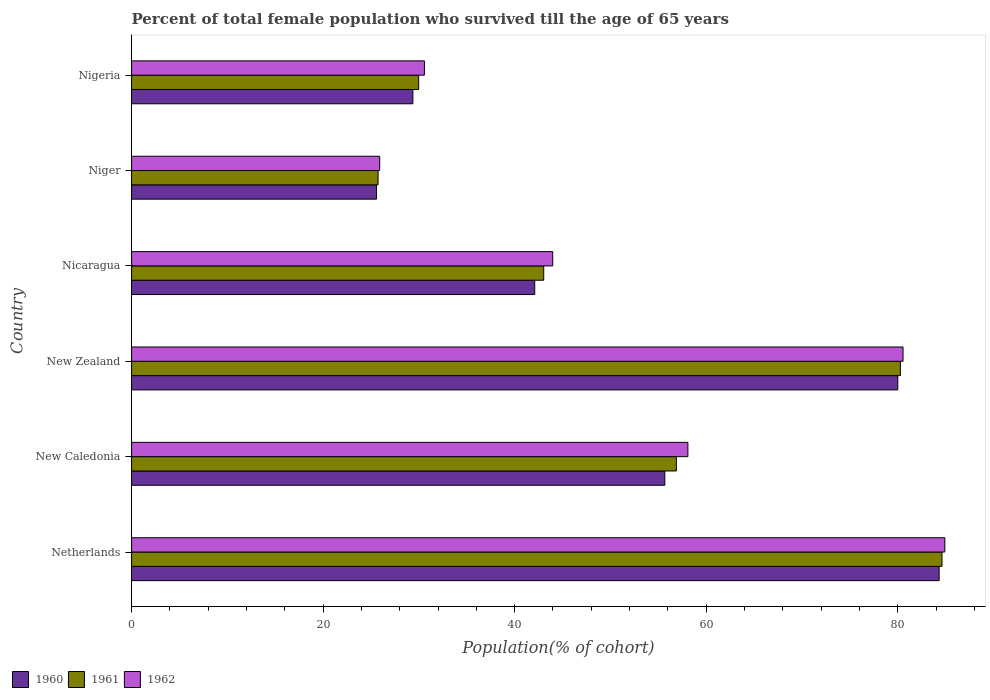How many different coloured bars are there?
Make the answer very short. 3. How many groups of bars are there?
Keep it short and to the point. 6. Are the number of bars on each tick of the Y-axis equal?
Give a very brief answer. Yes. How many bars are there on the 6th tick from the bottom?
Offer a terse response. 3. What is the label of the 6th group of bars from the top?
Your answer should be very brief. Netherlands. What is the percentage of total female population who survived till the age of 65 years in 1960 in Netherlands?
Your answer should be very brief. 84.32. Across all countries, what is the maximum percentage of total female population who survived till the age of 65 years in 1962?
Provide a short and direct response. 84.91. Across all countries, what is the minimum percentage of total female population who survived till the age of 65 years in 1962?
Your response must be concise. 25.91. In which country was the percentage of total female population who survived till the age of 65 years in 1961 minimum?
Ensure brevity in your answer.  Niger. What is the total percentage of total female population who survived till the age of 65 years in 1960 in the graph?
Give a very brief answer. 317.03. What is the difference between the percentage of total female population who survived till the age of 65 years in 1962 in Netherlands and that in Nigeria?
Keep it short and to the point. 54.34. What is the difference between the percentage of total female population who survived till the age of 65 years in 1962 in Niger and the percentage of total female population who survived till the age of 65 years in 1961 in New Caledonia?
Keep it short and to the point. -30.97. What is the average percentage of total female population who survived till the age of 65 years in 1960 per country?
Offer a very short reply. 52.84. What is the difference between the percentage of total female population who survived till the age of 65 years in 1962 and percentage of total female population who survived till the age of 65 years in 1960 in Niger?
Your answer should be very brief. 0.34. In how many countries, is the percentage of total female population who survived till the age of 65 years in 1962 greater than 84 %?
Make the answer very short. 1. What is the ratio of the percentage of total female population who survived till the age of 65 years in 1961 in New Zealand to that in Nigeria?
Ensure brevity in your answer.  2.68. Is the percentage of total female population who survived till the age of 65 years in 1962 in New Caledonia less than that in Nicaragua?
Your response must be concise. No. Is the difference between the percentage of total female population who survived till the age of 65 years in 1962 in Netherlands and New Zealand greater than the difference between the percentage of total female population who survived till the age of 65 years in 1960 in Netherlands and New Zealand?
Your answer should be compact. Yes. What is the difference between the highest and the second highest percentage of total female population who survived till the age of 65 years in 1960?
Keep it short and to the point. 4.32. What is the difference between the highest and the lowest percentage of total female population who survived till the age of 65 years in 1960?
Provide a succinct answer. 58.75. Is it the case that in every country, the sum of the percentage of total female population who survived till the age of 65 years in 1960 and percentage of total female population who survived till the age of 65 years in 1962 is greater than the percentage of total female population who survived till the age of 65 years in 1961?
Your answer should be compact. Yes. Are all the bars in the graph horizontal?
Make the answer very short. Yes. How many countries are there in the graph?
Your answer should be compact. 6. What is the difference between two consecutive major ticks on the X-axis?
Provide a succinct answer. 20. Does the graph contain any zero values?
Your answer should be very brief. No. Does the graph contain grids?
Provide a short and direct response. No. How many legend labels are there?
Your response must be concise. 3. How are the legend labels stacked?
Provide a short and direct response. Horizontal. What is the title of the graph?
Your response must be concise. Percent of total female population who survived till the age of 65 years. Does "2003" appear as one of the legend labels in the graph?
Make the answer very short. No. What is the label or title of the X-axis?
Make the answer very short. Population(% of cohort). What is the label or title of the Y-axis?
Offer a very short reply. Country. What is the Population(% of cohort) of 1960 in Netherlands?
Give a very brief answer. 84.32. What is the Population(% of cohort) of 1961 in Netherlands?
Make the answer very short. 84.62. What is the Population(% of cohort) in 1962 in Netherlands?
Offer a terse response. 84.91. What is the Population(% of cohort) of 1960 in New Caledonia?
Provide a succinct answer. 55.68. What is the Population(% of cohort) in 1961 in New Caledonia?
Provide a succinct answer. 56.88. What is the Population(% of cohort) in 1962 in New Caledonia?
Give a very brief answer. 58.09. What is the Population(% of cohort) of 1960 in New Zealand?
Keep it short and to the point. 80. What is the Population(% of cohort) of 1961 in New Zealand?
Ensure brevity in your answer.  80.28. What is the Population(% of cohort) in 1962 in New Zealand?
Make the answer very short. 80.55. What is the Population(% of cohort) in 1960 in Nicaragua?
Your response must be concise. 42.09. What is the Population(% of cohort) in 1961 in Nicaragua?
Give a very brief answer. 43.03. What is the Population(% of cohort) in 1962 in Nicaragua?
Your answer should be compact. 43.97. What is the Population(% of cohort) of 1960 in Niger?
Provide a short and direct response. 25.57. What is the Population(% of cohort) in 1961 in Niger?
Provide a succinct answer. 25.74. What is the Population(% of cohort) of 1962 in Niger?
Offer a very short reply. 25.91. What is the Population(% of cohort) of 1960 in Nigeria?
Offer a very short reply. 29.37. What is the Population(% of cohort) in 1961 in Nigeria?
Offer a terse response. 29.97. What is the Population(% of cohort) in 1962 in Nigeria?
Provide a short and direct response. 30.58. Across all countries, what is the maximum Population(% of cohort) of 1960?
Make the answer very short. 84.32. Across all countries, what is the maximum Population(% of cohort) in 1961?
Offer a terse response. 84.62. Across all countries, what is the maximum Population(% of cohort) in 1962?
Provide a succinct answer. 84.91. Across all countries, what is the minimum Population(% of cohort) of 1960?
Your answer should be very brief. 25.57. Across all countries, what is the minimum Population(% of cohort) in 1961?
Offer a terse response. 25.74. Across all countries, what is the minimum Population(% of cohort) of 1962?
Offer a terse response. 25.91. What is the total Population(% of cohort) in 1960 in the graph?
Keep it short and to the point. 317.03. What is the total Population(% of cohort) in 1961 in the graph?
Offer a terse response. 320.51. What is the total Population(% of cohort) in 1962 in the graph?
Offer a terse response. 324. What is the difference between the Population(% of cohort) of 1960 in Netherlands and that in New Caledonia?
Your answer should be very brief. 28.64. What is the difference between the Population(% of cohort) of 1961 in Netherlands and that in New Caledonia?
Provide a short and direct response. 27.74. What is the difference between the Population(% of cohort) in 1962 in Netherlands and that in New Caledonia?
Make the answer very short. 26.83. What is the difference between the Population(% of cohort) of 1960 in Netherlands and that in New Zealand?
Keep it short and to the point. 4.32. What is the difference between the Population(% of cohort) in 1961 in Netherlands and that in New Zealand?
Your response must be concise. 4.34. What is the difference between the Population(% of cohort) of 1962 in Netherlands and that in New Zealand?
Your answer should be compact. 4.36. What is the difference between the Population(% of cohort) of 1960 in Netherlands and that in Nicaragua?
Your answer should be compact. 42.23. What is the difference between the Population(% of cohort) in 1961 in Netherlands and that in Nicaragua?
Your response must be concise. 41.58. What is the difference between the Population(% of cohort) of 1962 in Netherlands and that in Nicaragua?
Your response must be concise. 40.94. What is the difference between the Population(% of cohort) of 1960 in Netherlands and that in Niger?
Offer a terse response. 58.75. What is the difference between the Population(% of cohort) in 1961 in Netherlands and that in Niger?
Your answer should be very brief. 58.88. What is the difference between the Population(% of cohort) of 1962 in Netherlands and that in Niger?
Your answer should be very brief. 59.01. What is the difference between the Population(% of cohort) in 1960 in Netherlands and that in Nigeria?
Your answer should be very brief. 54.95. What is the difference between the Population(% of cohort) in 1961 in Netherlands and that in Nigeria?
Your answer should be very brief. 54.64. What is the difference between the Population(% of cohort) of 1962 in Netherlands and that in Nigeria?
Your answer should be compact. 54.34. What is the difference between the Population(% of cohort) in 1960 in New Caledonia and that in New Zealand?
Provide a short and direct response. -24.33. What is the difference between the Population(% of cohort) of 1961 in New Caledonia and that in New Zealand?
Provide a short and direct response. -23.4. What is the difference between the Population(% of cohort) of 1962 in New Caledonia and that in New Zealand?
Offer a very short reply. -22.46. What is the difference between the Population(% of cohort) of 1960 in New Caledonia and that in Nicaragua?
Ensure brevity in your answer.  13.58. What is the difference between the Population(% of cohort) in 1961 in New Caledonia and that in Nicaragua?
Provide a succinct answer. 13.85. What is the difference between the Population(% of cohort) in 1962 in New Caledonia and that in Nicaragua?
Your answer should be compact. 14.11. What is the difference between the Population(% of cohort) in 1960 in New Caledonia and that in Niger?
Your answer should be compact. 30.11. What is the difference between the Population(% of cohort) of 1961 in New Caledonia and that in Niger?
Keep it short and to the point. 31.14. What is the difference between the Population(% of cohort) in 1962 in New Caledonia and that in Niger?
Your response must be concise. 32.18. What is the difference between the Population(% of cohort) in 1960 in New Caledonia and that in Nigeria?
Provide a short and direct response. 26.3. What is the difference between the Population(% of cohort) of 1961 in New Caledonia and that in Nigeria?
Offer a terse response. 26.91. What is the difference between the Population(% of cohort) in 1962 in New Caledonia and that in Nigeria?
Make the answer very short. 27.51. What is the difference between the Population(% of cohort) in 1960 in New Zealand and that in Nicaragua?
Ensure brevity in your answer.  37.91. What is the difference between the Population(% of cohort) in 1961 in New Zealand and that in Nicaragua?
Keep it short and to the point. 37.24. What is the difference between the Population(% of cohort) in 1962 in New Zealand and that in Nicaragua?
Offer a very short reply. 36.58. What is the difference between the Population(% of cohort) of 1960 in New Zealand and that in Niger?
Provide a short and direct response. 54.43. What is the difference between the Population(% of cohort) of 1961 in New Zealand and that in Niger?
Your answer should be compact. 54.54. What is the difference between the Population(% of cohort) in 1962 in New Zealand and that in Niger?
Ensure brevity in your answer.  54.64. What is the difference between the Population(% of cohort) of 1960 in New Zealand and that in Nigeria?
Ensure brevity in your answer.  50.63. What is the difference between the Population(% of cohort) in 1961 in New Zealand and that in Nigeria?
Your answer should be very brief. 50.3. What is the difference between the Population(% of cohort) in 1962 in New Zealand and that in Nigeria?
Provide a short and direct response. 49.97. What is the difference between the Population(% of cohort) in 1960 in Nicaragua and that in Niger?
Your response must be concise. 16.53. What is the difference between the Population(% of cohort) of 1961 in Nicaragua and that in Niger?
Your response must be concise. 17.3. What is the difference between the Population(% of cohort) in 1962 in Nicaragua and that in Niger?
Offer a very short reply. 18.07. What is the difference between the Population(% of cohort) of 1960 in Nicaragua and that in Nigeria?
Your answer should be compact. 12.72. What is the difference between the Population(% of cohort) in 1961 in Nicaragua and that in Nigeria?
Give a very brief answer. 13.06. What is the difference between the Population(% of cohort) in 1962 in Nicaragua and that in Nigeria?
Make the answer very short. 13.4. What is the difference between the Population(% of cohort) of 1960 in Niger and that in Nigeria?
Your answer should be very brief. -3.8. What is the difference between the Population(% of cohort) in 1961 in Niger and that in Nigeria?
Your answer should be very brief. -4.24. What is the difference between the Population(% of cohort) of 1962 in Niger and that in Nigeria?
Your answer should be compact. -4.67. What is the difference between the Population(% of cohort) in 1960 in Netherlands and the Population(% of cohort) in 1961 in New Caledonia?
Keep it short and to the point. 27.44. What is the difference between the Population(% of cohort) in 1960 in Netherlands and the Population(% of cohort) in 1962 in New Caledonia?
Offer a very short reply. 26.23. What is the difference between the Population(% of cohort) in 1961 in Netherlands and the Population(% of cohort) in 1962 in New Caledonia?
Provide a short and direct response. 26.53. What is the difference between the Population(% of cohort) in 1960 in Netherlands and the Population(% of cohort) in 1961 in New Zealand?
Provide a short and direct response. 4.04. What is the difference between the Population(% of cohort) of 1960 in Netherlands and the Population(% of cohort) of 1962 in New Zealand?
Ensure brevity in your answer.  3.77. What is the difference between the Population(% of cohort) in 1961 in Netherlands and the Population(% of cohort) in 1962 in New Zealand?
Keep it short and to the point. 4.07. What is the difference between the Population(% of cohort) of 1960 in Netherlands and the Population(% of cohort) of 1961 in Nicaragua?
Your response must be concise. 41.29. What is the difference between the Population(% of cohort) of 1960 in Netherlands and the Population(% of cohort) of 1962 in Nicaragua?
Your answer should be compact. 40.35. What is the difference between the Population(% of cohort) in 1961 in Netherlands and the Population(% of cohort) in 1962 in Nicaragua?
Make the answer very short. 40.64. What is the difference between the Population(% of cohort) in 1960 in Netherlands and the Population(% of cohort) in 1961 in Niger?
Ensure brevity in your answer.  58.58. What is the difference between the Population(% of cohort) in 1960 in Netherlands and the Population(% of cohort) in 1962 in Niger?
Your answer should be compact. 58.41. What is the difference between the Population(% of cohort) of 1961 in Netherlands and the Population(% of cohort) of 1962 in Niger?
Offer a very short reply. 58.71. What is the difference between the Population(% of cohort) in 1960 in Netherlands and the Population(% of cohort) in 1961 in Nigeria?
Provide a short and direct response. 54.35. What is the difference between the Population(% of cohort) of 1960 in Netherlands and the Population(% of cohort) of 1962 in Nigeria?
Offer a very short reply. 53.74. What is the difference between the Population(% of cohort) of 1961 in Netherlands and the Population(% of cohort) of 1962 in Nigeria?
Keep it short and to the point. 54.04. What is the difference between the Population(% of cohort) of 1960 in New Caledonia and the Population(% of cohort) of 1961 in New Zealand?
Make the answer very short. -24.6. What is the difference between the Population(% of cohort) of 1960 in New Caledonia and the Population(% of cohort) of 1962 in New Zealand?
Make the answer very short. -24.87. What is the difference between the Population(% of cohort) of 1961 in New Caledonia and the Population(% of cohort) of 1962 in New Zealand?
Ensure brevity in your answer.  -23.67. What is the difference between the Population(% of cohort) of 1960 in New Caledonia and the Population(% of cohort) of 1961 in Nicaragua?
Make the answer very short. 12.64. What is the difference between the Population(% of cohort) in 1960 in New Caledonia and the Population(% of cohort) in 1962 in Nicaragua?
Make the answer very short. 11.7. What is the difference between the Population(% of cohort) in 1961 in New Caledonia and the Population(% of cohort) in 1962 in Nicaragua?
Offer a terse response. 12.91. What is the difference between the Population(% of cohort) of 1960 in New Caledonia and the Population(% of cohort) of 1961 in Niger?
Offer a terse response. 29.94. What is the difference between the Population(% of cohort) of 1960 in New Caledonia and the Population(% of cohort) of 1962 in Niger?
Make the answer very short. 29.77. What is the difference between the Population(% of cohort) in 1961 in New Caledonia and the Population(% of cohort) in 1962 in Niger?
Give a very brief answer. 30.97. What is the difference between the Population(% of cohort) of 1960 in New Caledonia and the Population(% of cohort) of 1961 in Nigeria?
Give a very brief answer. 25.7. What is the difference between the Population(% of cohort) in 1960 in New Caledonia and the Population(% of cohort) in 1962 in Nigeria?
Your response must be concise. 25.1. What is the difference between the Population(% of cohort) in 1961 in New Caledonia and the Population(% of cohort) in 1962 in Nigeria?
Ensure brevity in your answer.  26.3. What is the difference between the Population(% of cohort) in 1960 in New Zealand and the Population(% of cohort) in 1961 in Nicaragua?
Your answer should be compact. 36.97. What is the difference between the Population(% of cohort) in 1960 in New Zealand and the Population(% of cohort) in 1962 in Nicaragua?
Your answer should be very brief. 36.03. What is the difference between the Population(% of cohort) in 1961 in New Zealand and the Population(% of cohort) in 1962 in Nicaragua?
Your response must be concise. 36.3. What is the difference between the Population(% of cohort) of 1960 in New Zealand and the Population(% of cohort) of 1961 in Niger?
Make the answer very short. 54.27. What is the difference between the Population(% of cohort) of 1960 in New Zealand and the Population(% of cohort) of 1962 in Niger?
Your answer should be very brief. 54.1. What is the difference between the Population(% of cohort) in 1961 in New Zealand and the Population(% of cohort) in 1962 in Niger?
Your response must be concise. 54.37. What is the difference between the Population(% of cohort) in 1960 in New Zealand and the Population(% of cohort) in 1961 in Nigeria?
Offer a very short reply. 50.03. What is the difference between the Population(% of cohort) of 1960 in New Zealand and the Population(% of cohort) of 1962 in Nigeria?
Offer a terse response. 49.43. What is the difference between the Population(% of cohort) in 1961 in New Zealand and the Population(% of cohort) in 1962 in Nigeria?
Make the answer very short. 49.7. What is the difference between the Population(% of cohort) in 1960 in Nicaragua and the Population(% of cohort) in 1961 in Niger?
Offer a very short reply. 16.36. What is the difference between the Population(% of cohort) in 1960 in Nicaragua and the Population(% of cohort) in 1962 in Niger?
Keep it short and to the point. 16.19. What is the difference between the Population(% of cohort) of 1961 in Nicaragua and the Population(% of cohort) of 1962 in Niger?
Make the answer very short. 17.13. What is the difference between the Population(% of cohort) of 1960 in Nicaragua and the Population(% of cohort) of 1961 in Nigeria?
Your response must be concise. 12.12. What is the difference between the Population(% of cohort) in 1960 in Nicaragua and the Population(% of cohort) in 1962 in Nigeria?
Provide a short and direct response. 11.52. What is the difference between the Population(% of cohort) of 1961 in Nicaragua and the Population(% of cohort) of 1962 in Nigeria?
Provide a succinct answer. 12.46. What is the difference between the Population(% of cohort) of 1960 in Niger and the Population(% of cohort) of 1961 in Nigeria?
Offer a very short reply. -4.41. What is the difference between the Population(% of cohort) of 1960 in Niger and the Population(% of cohort) of 1962 in Nigeria?
Your response must be concise. -5.01. What is the difference between the Population(% of cohort) of 1961 in Niger and the Population(% of cohort) of 1962 in Nigeria?
Provide a succinct answer. -4.84. What is the average Population(% of cohort) of 1960 per country?
Offer a very short reply. 52.84. What is the average Population(% of cohort) of 1961 per country?
Your response must be concise. 53.42. What is the average Population(% of cohort) in 1962 per country?
Offer a very short reply. 54. What is the difference between the Population(% of cohort) of 1960 and Population(% of cohort) of 1961 in Netherlands?
Ensure brevity in your answer.  -0.3. What is the difference between the Population(% of cohort) in 1960 and Population(% of cohort) in 1962 in Netherlands?
Ensure brevity in your answer.  -0.59. What is the difference between the Population(% of cohort) in 1961 and Population(% of cohort) in 1962 in Netherlands?
Provide a short and direct response. -0.3. What is the difference between the Population(% of cohort) in 1960 and Population(% of cohort) in 1961 in New Caledonia?
Provide a short and direct response. -1.21. What is the difference between the Population(% of cohort) of 1960 and Population(% of cohort) of 1962 in New Caledonia?
Give a very brief answer. -2.41. What is the difference between the Population(% of cohort) of 1961 and Population(% of cohort) of 1962 in New Caledonia?
Your answer should be compact. -1.21. What is the difference between the Population(% of cohort) in 1960 and Population(% of cohort) in 1961 in New Zealand?
Give a very brief answer. -0.27. What is the difference between the Population(% of cohort) in 1960 and Population(% of cohort) in 1962 in New Zealand?
Ensure brevity in your answer.  -0.55. What is the difference between the Population(% of cohort) of 1961 and Population(% of cohort) of 1962 in New Zealand?
Make the answer very short. -0.27. What is the difference between the Population(% of cohort) in 1960 and Population(% of cohort) in 1961 in Nicaragua?
Keep it short and to the point. -0.94. What is the difference between the Population(% of cohort) of 1960 and Population(% of cohort) of 1962 in Nicaragua?
Offer a terse response. -1.88. What is the difference between the Population(% of cohort) of 1961 and Population(% of cohort) of 1962 in Nicaragua?
Make the answer very short. -0.94. What is the difference between the Population(% of cohort) of 1960 and Population(% of cohort) of 1961 in Niger?
Your answer should be very brief. -0.17. What is the difference between the Population(% of cohort) in 1960 and Population(% of cohort) in 1962 in Niger?
Your response must be concise. -0.34. What is the difference between the Population(% of cohort) in 1961 and Population(% of cohort) in 1962 in Niger?
Make the answer very short. -0.17. What is the difference between the Population(% of cohort) in 1960 and Population(% of cohort) in 1961 in Nigeria?
Your response must be concise. -0.6. What is the difference between the Population(% of cohort) of 1960 and Population(% of cohort) of 1962 in Nigeria?
Offer a very short reply. -1.21. What is the difference between the Population(% of cohort) in 1961 and Population(% of cohort) in 1962 in Nigeria?
Offer a very short reply. -0.6. What is the ratio of the Population(% of cohort) in 1960 in Netherlands to that in New Caledonia?
Give a very brief answer. 1.51. What is the ratio of the Population(% of cohort) in 1961 in Netherlands to that in New Caledonia?
Your response must be concise. 1.49. What is the ratio of the Population(% of cohort) in 1962 in Netherlands to that in New Caledonia?
Ensure brevity in your answer.  1.46. What is the ratio of the Population(% of cohort) of 1960 in Netherlands to that in New Zealand?
Give a very brief answer. 1.05. What is the ratio of the Population(% of cohort) in 1961 in Netherlands to that in New Zealand?
Provide a succinct answer. 1.05. What is the ratio of the Population(% of cohort) of 1962 in Netherlands to that in New Zealand?
Keep it short and to the point. 1.05. What is the ratio of the Population(% of cohort) of 1960 in Netherlands to that in Nicaragua?
Give a very brief answer. 2. What is the ratio of the Population(% of cohort) of 1961 in Netherlands to that in Nicaragua?
Offer a very short reply. 1.97. What is the ratio of the Population(% of cohort) of 1962 in Netherlands to that in Nicaragua?
Your response must be concise. 1.93. What is the ratio of the Population(% of cohort) of 1960 in Netherlands to that in Niger?
Keep it short and to the point. 3.3. What is the ratio of the Population(% of cohort) of 1961 in Netherlands to that in Niger?
Keep it short and to the point. 3.29. What is the ratio of the Population(% of cohort) of 1962 in Netherlands to that in Niger?
Give a very brief answer. 3.28. What is the ratio of the Population(% of cohort) in 1960 in Netherlands to that in Nigeria?
Make the answer very short. 2.87. What is the ratio of the Population(% of cohort) in 1961 in Netherlands to that in Nigeria?
Provide a short and direct response. 2.82. What is the ratio of the Population(% of cohort) of 1962 in Netherlands to that in Nigeria?
Provide a succinct answer. 2.78. What is the ratio of the Population(% of cohort) of 1960 in New Caledonia to that in New Zealand?
Your answer should be compact. 0.7. What is the ratio of the Population(% of cohort) of 1961 in New Caledonia to that in New Zealand?
Keep it short and to the point. 0.71. What is the ratio of the Population(% of cohort) in 1962 in New Caledonia to that in New Zealand?
Give a very brief answer. 0.72. What is the ratio of the Population(% of cohort) of 1960 in New Caledonia to that in Nicaragua?
Keep it short and to the point. 1.32. What is the ratio of the Population(% of cohort) in 1961 in New Caledonia to that in Nicaragua?
Offer a very short reply. 1.32. What is the ratio of the Population(% of cohort) of 1962 in New Caledonia to that in Nicaragua?
Keep it short and to the point. 1.32. What is the ratio of the Population(% of cohort) in 1960 in New Caledonia to that in Niger?
Offer a terse response. 2.18. What is the ratio of the Population(% of cohort) in 1961 in New Caledonia to that in Niger?
Make the answer very short. 2.21. What is the ratio of the Population(% of cohort) of 1962 in New Caledonia to that in Niger?
Ensure brevity in your answer.  2.24. What is the ratio of the Population(% of cohort) of 1960 in New Caledonia to that in Nigeria?
Your answer should be compact. 1.9. What is the ratio of the Population(% of cohort) in 1961 in New Caledonia to that in Nigeria?
Provide a succinct answer. 1.9. What is the ratio of the Population(% of cohort) in 1962 in New Caledonia to that in Nigeria?
Make the answer very short. 1.9. What is the ratio of the Population(% of cohort) in 1960 in New Zealand to that in Nicaragua?
Offer a terse response. 1.9. What is the ratio of the Population(% of cohort) of 1961 in New Zealand to that in Nicaragua?
Give a very brief answer. 1.87. What is the ratio of the Population(% of cohort) of 1962 in New Zealand to that in Nicaragua?
Ensure brevity in your answer.  1.83. What is the ratio of the Population(% of cohort) in 1960 in New Zealand to that in Niger?
Offer a very short reply. 3.13. What is the ratio of the Population(% of cohort) in 1961 in New Zealand to that in Niger?
Make the answer very short. 3.12. What is the ratio of the Population(% of cohort) in 1962 in New Zealand to that in Niger?
Make the answer very short. 3.11. What is the ratio of the Population(% of cohort) in 1960 in New Zealand to that in Nigeria?
Keep it short and to the point. 2.72. What is the ratio of the Population(% of cohort) in 1961 in New Zealand to that in Nigeria?
Your answer should be compact. 2.68. What is the ratio of the Population(% of cohort) of 1962 in New Zealand to that in Nigeria?
Your answer should be very brief. 2.63. What is the ratio of the Population(% of cohort) of 1960 in Nicaragua to that in Niger?
Provide a succinct answer. 1.65. What is the ratio of the Population(% of cohort) in 1961 in Nicaragua to that in Niger?
Provide a succinct answer. 1.67. What is the ratio of the Population(% of cohort) in 1962 in Nicaragua to that in Niger?
Offer a very short reply. 1.7. What is the ratio of the Population(% of cohort) in 1960 in Nicaragua to that in Nigeria?
Keep it short and to the point. 1.43. What is the ratio of the Population(% of cohort) of 1961 in Nicaragua to that in Nigeria?
Make the answer very short. 1.44. What is the ratio of the Population(% of cohort) of 1962 in Nicaragua to that in Nigeria?
Ensure brevity in your answer.  1.44. What is the ratio of the Population(% of cohort) in 1960 in Niger to that in Nigeria?
Offer a terse response. 0.87. What is the ratio of the Population(% of cohort) of 1961 in Niger to that in Nigeria?
Provide a succinct answer. 0.86. What is the ratio of the Population(% of cohort) in 1962 in Niger to that in Nigeria?
Provide a short and direct response. 0.85. What is the difference between the highest and the second highest Population(% of cohort) in 1960?
Your response must be concise. 4.32. What is the difference between the highest and the second highest Population(% of cohort) of 1961?
Provide a short and direct response. 4.34. What is the difference between the highest and the second highest Population(% of cohort) in 1962?
Your answer should be very brief. 4.36. What is the difference between the highest and the lowest Population(% of cohort) in 1960?
Your response must be concise. 58.75. What is the difference between the highest and the lowest Population(% of cohort) in 1961?
Keep it short and to the point. 58.88. What is the difference between the highest and the lowest Population(% of cohort) in 1962?
Ensure brevity in your answer.  59.01. 